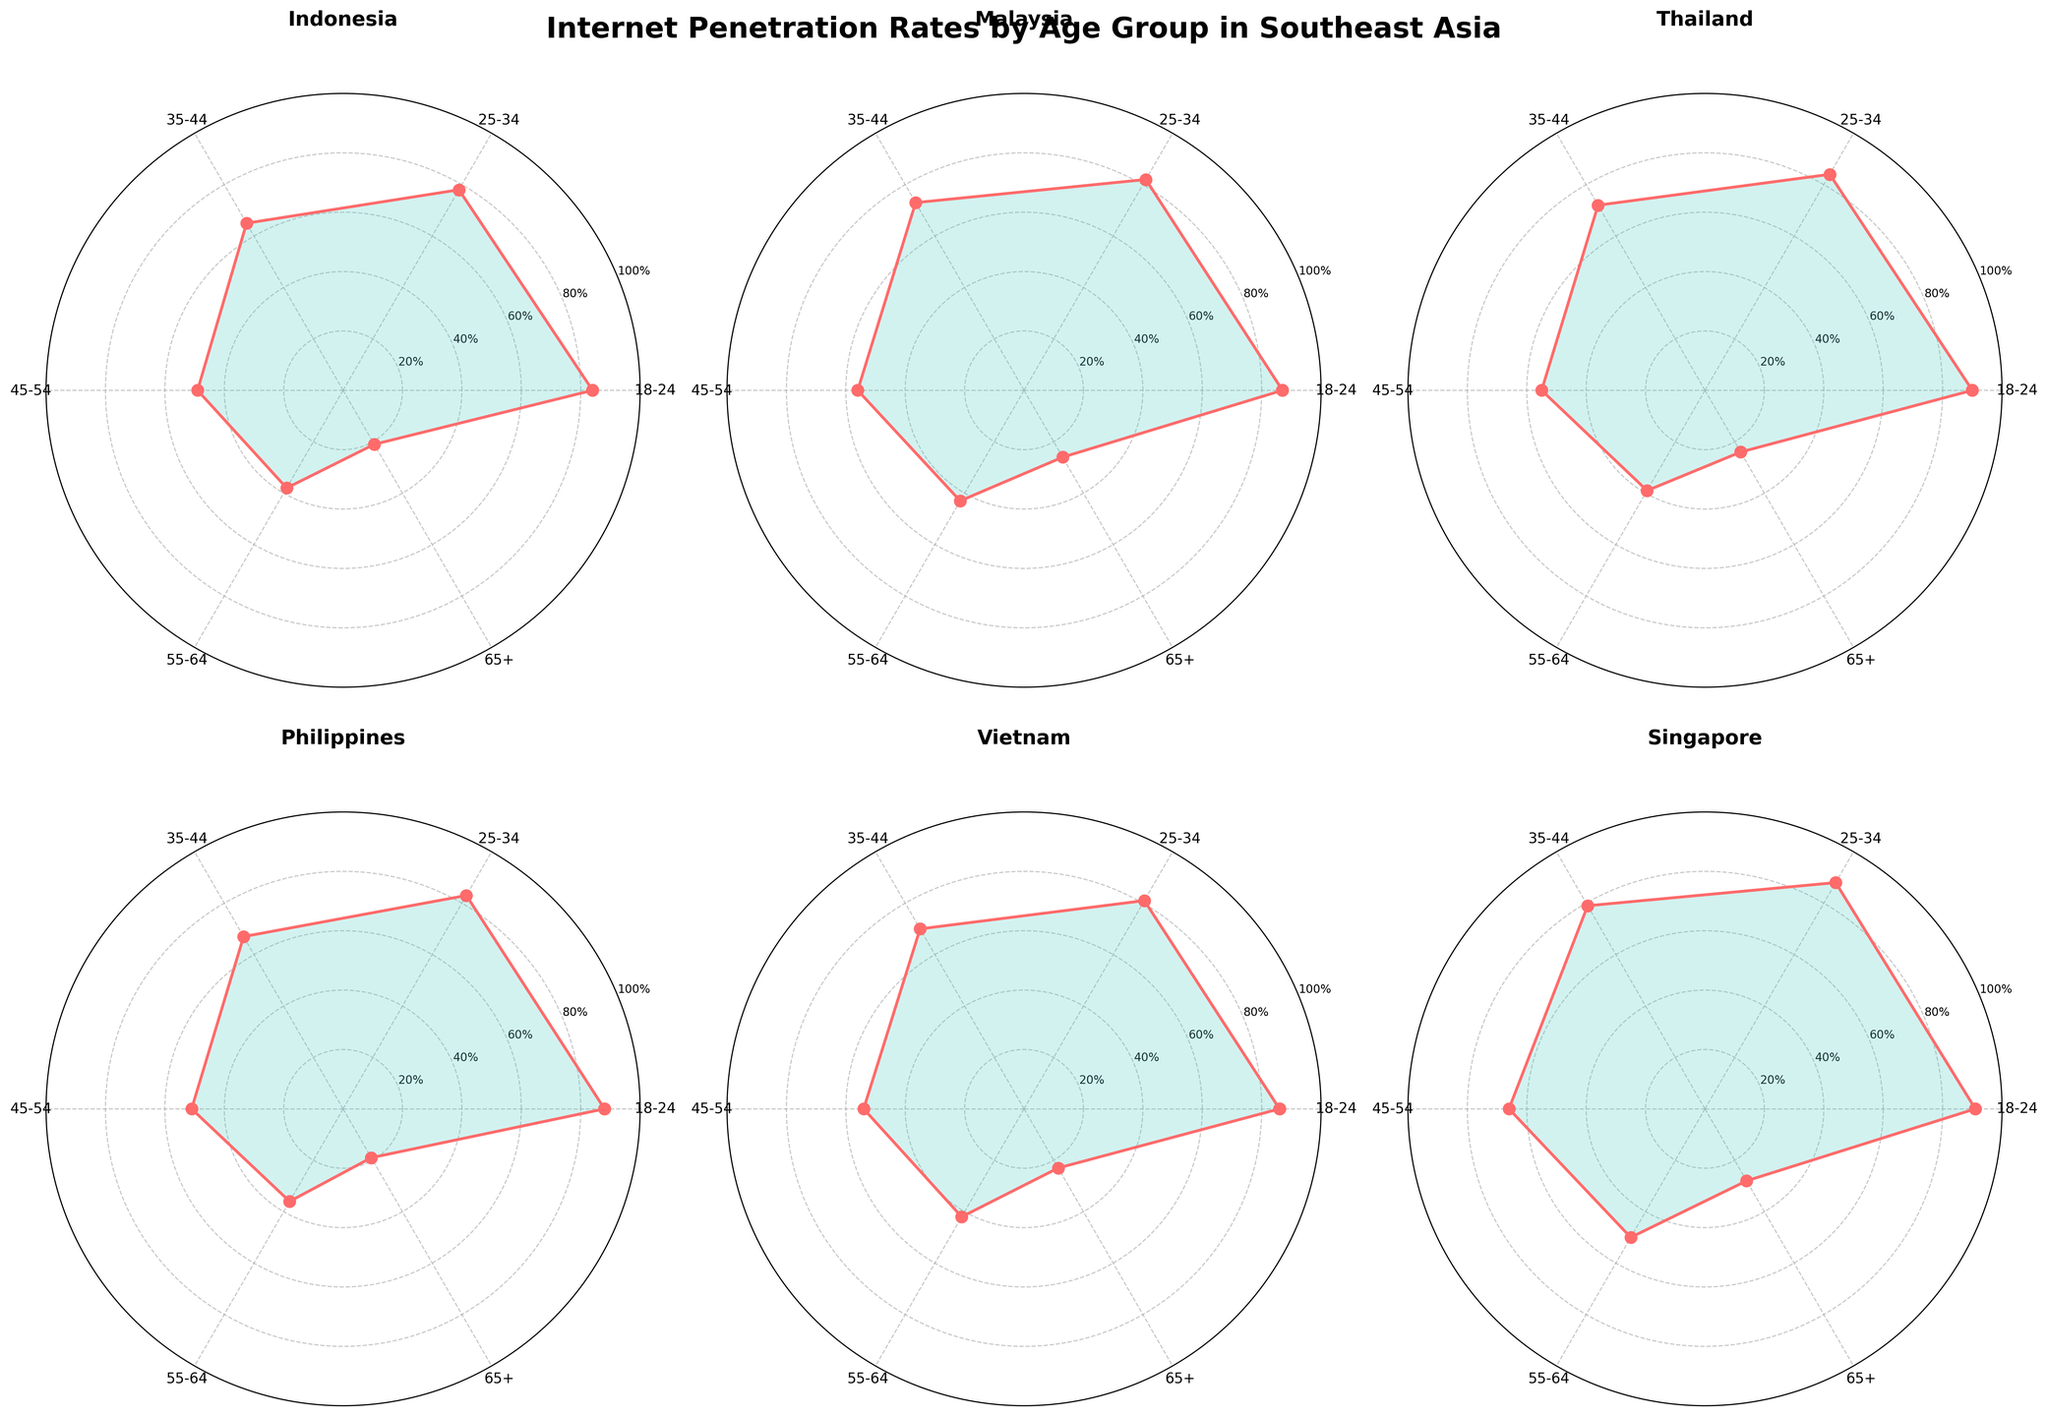what does the overall title of the figure tell you? The title of the figure is "Internet Penetration Rates by Age Group in Southeast Asia," indicating the focus of the data visualization is on the percentage of internet usage across various age groups in Southeast Asian countries.
Answer: It tells us the figure is about Internet penetration rates by age group in Southeast Asia Which country has the highest internet penetration rate for the age group 18-24? Looking at the subplot for each country, Singapore has the highest internet penetration rate for the age group 18-24 with 91%.
Answer: Singapore What is the internet penetration rate for the 65+ age group in Malaysia? Referring to the subplot for Malaysia and reading the value for the 65+ age group, the rate is 26%.
Answer: 26% How does the internet penetration rate for the 55-64 age group in Indonesia compare to that in Thailand? By comparing the plots for Indonesia and Thailand, Indonesia has a 38% internet penetration rate for the 55-64 age group, while Thailand has 39%. Thailand's rate is slightly higher.
Answer: Thailand's rate is higher Which age group has the lowest internet penetration rate in the Philippines? The radar plot for the Philippines shows that the 65+ age group has the lowest internet penetration rate at 19%.
Answer: 65+ How does the variance in internet penetration rates across all age groups compare between Indonesia and Singapore? Singapore shows a more consistent internet penetration rate across age groups with less drastic drops, whereas Indonesia shows a significant drop in internet penetration rates as the age group increases. This means Singapore has lower variance compared to Indonesia.
Answer: Singapore has lower variance In Vietnam, what is the difference in internet penetration rates between the 25-34 and 35-44 age groups? The plot for Vietnam indicates the penetration rate for the 25-34 age group is 81% and for the 35-44 age group is 70%. The difference is 81% - 70% = 11%.
Answer: 11% Which country shows the least penetration percentage for the 45-54 age group, and what is the value? Looking across all subplots for the 45-54 age group, Indonesia has the least penetration percentage with 49%.
Answer: Indonesia, 49% What trend do you observe in internet penetration rates across age groups in Southeast Asia? Across all countries, the trend indicates that internet penetration rates decrease as the age group increases. The younger age groups (18-24 and 25-34) generally have the highest penetration rates, while the older age groups (55-64 and 65+) have the lowest.
Answer: A decreasing trend with increasing age How do the internet penetration rates in the 35-44 age group differ between Indonesia and the Philippines? The plot shows Indonesia has a penetration rate of 65% and the Philippines has 67% for the 35-44 age group. The Philippines has 2% higher penetration in this age group.
Answer: Philippines is 2% higher 